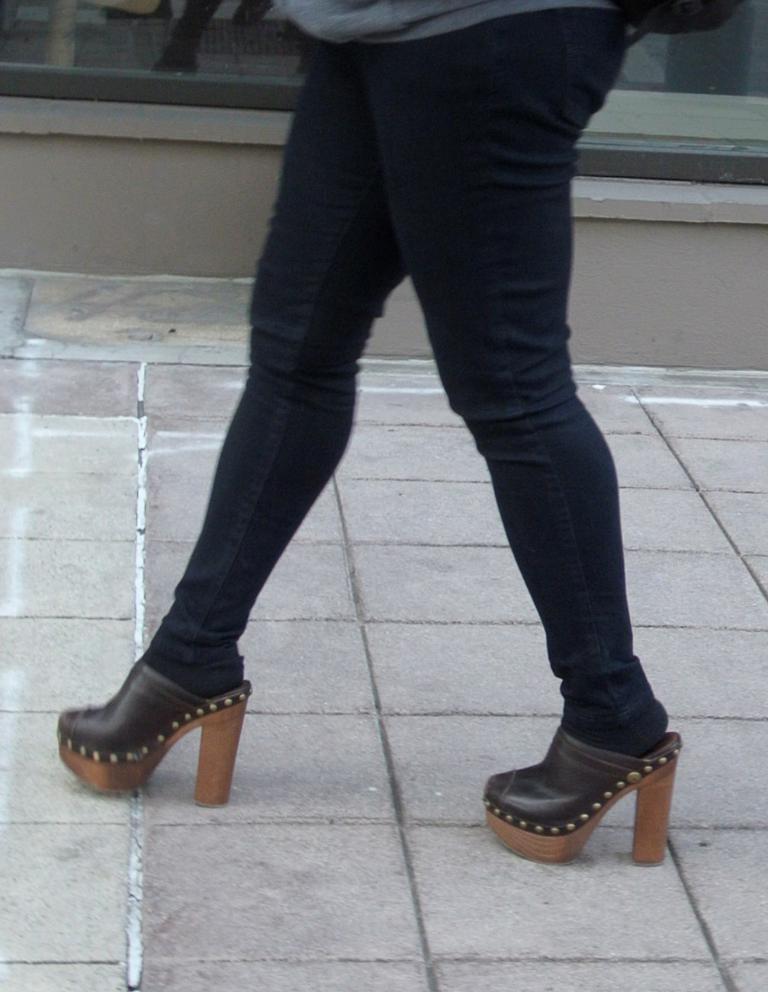Please provide a concise description of this image. This image is taken outdoors. At the bottom of the image there is a floor. In the background there is a wall. In the middle of the image a woman is walking on the floor. 